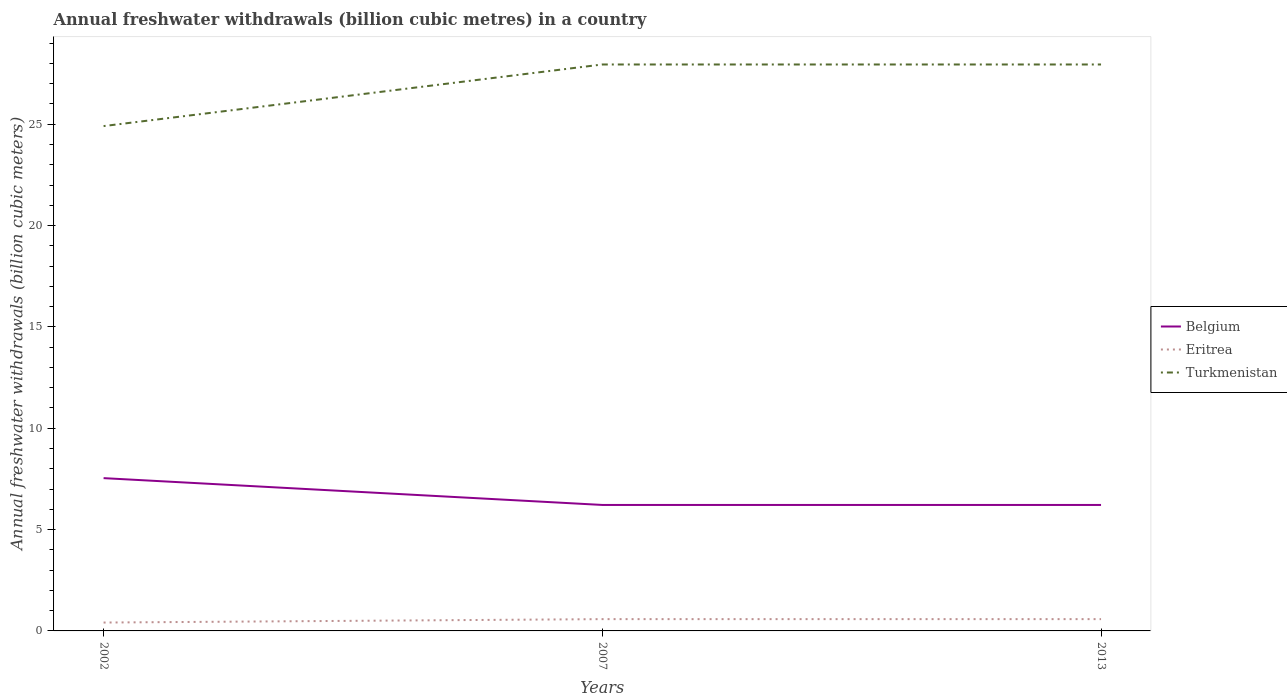Across all years, what is the maximum annual freshwater withdrawals in Belgium?
Give a very brief answer. 6.22. What is the total annual freshwater withdrawals in Eritrea in the graph?
Provide a succinct answer. 0. What is the difference between the highest and the second highest annual freshwater withdrawals in Turkmenistan?
Your answer should be very brief. 3.04. How many years are there in the graph?
Provide a succinct answer. 3. Does the graph contain any zero values?
Give a very brief answer. No. Where does the legend appear in the graph?
Your answer should be compact. Center right. How are the legend labels stacked?
Your response must be concise. Vertical. What is the title of the graph?
Ensure brevity in your answer.  Annual freshwater withdrawals (billion cubic metres) in a country. What is the label or title of the Y-axis?
Offer a very short reply. Annual freshwater withdrawals (billion cubic meters). What is the Annual freshwater withdrawals (billion cubic meters) in Belgium in 2002?
Make the answer very short. 7.54. What is the Annual freshwater withdrawals (billion cubic meters) of Eritrea in 2002?
Your response must be concise. 0.41. What is the Annual freshwater withdrawals (billion cubic meters) of Turkmenistan in 2002?
Keep it short and to the point. 24.91. What is the Annual freshwater withdrawals (billion cubic meters) of Belgium in 2007?
Ensure brevity in your answer.  6.22. What is the Annual freshwater withdrawals (billion cubic meters) of Eritrea in 2007?
Make the answer very short. 0.58. What is the Annual freshwater withdrawals (billion cubic meters) in Turkmenistan in 2007?
Your response must be concise. 27.95. What is the Annual freshwater withdrawals (billion cubic meters) in Belgium in 2013?
Offer a terse response. 6.22. What is the Annual freshwater withdrawals (billion cubic meters) of Eritrea in 2013?
Ensure brevity in your answer.  0.58. What is the Annual freshwater withdrawals (billion cubic meters) in Turkmenistan in 2013?
Make the answer very short. 27.95. Across all years, what is the maximum Annual freshwater withdrawals (billion cubic meters) in Belgium?
Keep it short and to the point. 7.54. Across all years, what is the maximum Annual freshwater withdrawals (billion cubic meters) of Eritrea?
Keep it short and to the point. 0.58. Across all years, what is the maximum Annual freshwater withdrawals (billion cubic meters) in Turkmenistan?
Make the answer very short. 27.95. Across all years, what is the minimum Annual freshwater withdrawals (billion cubic meters) in Belgium?
Provide a succinct answer. 6.22. Across all years, what is the minimum Annual freshwater withdrawals (billion cubic meters) in Eritrea?
Offer a very short reply. 0.41. Across all years, what is the minimum Annual freshwater withdrawals (billion cubic meters) of Turkmenistan?
Keep it short and to the point. 24.91. What is the total Annual freshwater withdrawals (billion cubic meters) in Belgium in the graph?
Your answer should be very brief. 19.97. What is the total Annual freshwater withdrawals (billion cubic meters) in Eritrea in the graph?
Your answer should be very brief. 1.58. What is the total Annual freshwater withdrawals (billion cubic meters) of Turkmenistan in the graph?
Make the answer very short. 80.81. What is the difference between the Annual freshwater withdrawals (billion cubic meters) of Belgium in 2002 and that in 2007?
Your response must be concise. 1.32. What is the difference between the Annual freshwater withdrawals (billion cubic meters) of Eritrea in 2002 and that in 2007?
Your answer should be very brief. -0.17. What is the difference between the Annual freshwater withdrawals (billion cubic meters) of Turkmenistan in 2002 and that in 2007?
Your response must be concise. -3.04. What is the difference between the Annual freshwater withdrawals (billion cubic meters) of Belgium in 2002 and that in 2013?
Keep it short and to the point. 1.32. What is the difference between the Annual freshwater withdrawals (billion cubic meters) in Eritrea in 2002 and that in 2013?
Provide a succinct answer. -0.17. What is the difference between the Annual freshwater withdrawals (billion cubic meters) of Turkmenistan in 2002 and that in 2013?
Your answer should be very brief. -3.04. What is the difference between the Annual freshwater withdrawals (billion cubic meters) of Belgium in 2002 and the Annual freshwater withdrawals (billion cubic meters) of Eritrea in 2007?
Your response must be concise. 6.96. What is the difference between the Annual freshwater withdrawals (billion cubic meters) of Belgium in 2002 and the Annual freshwater withdrawals (billion cubic meters) of Turkmenistan in 2007?
Ensure brevity in your answer.  -20.41. What is the difference between the Annual freshwater withdrawals (billion cubic meters) of Eritrea in 2002 and the Annual freshwater withdrawals (billion cubic meters) of Turkmenistan in 2007?
Keep it short and to the point. -27.54. What is the difference between the Annual freshwater withdrawals (billion cubic meters) of Belgium in 2002 and the Annual freshwater withdrawals (billion cubic meters) of Eritrea in 2013?
Provide a succinct answer. 6.96. What is the difference between the Annual freshwater withdrawals (billion cubic meters) in Belgium in 2002 and the Annual freshwater withdrawals (billion cubic meters) in Turkmenistan in 2013?
Make the answer very short. -20.41. What is the difference between the Annual freshwater withdrawals (billion cubic meters) of Eritrea in 2002 and the Annual freshwater withdrawals (billion cubic meters) of Turkmenistan in 2013?
Keep it short and to the point. -27.54. What is the difference between the Annual freshwater withdrawals (billion cubic meters) of Belgium in 2007 and the Annual freshwater withdrawals (billion cubic meters) of Eritrea in 2013?
Keep it short and to the point. 5.63. What is the difference between the Annual freshwater withdrawals (billion cubic meters) of Belgium in 2007 and the Annual freshwater withdrawals (billion cubic meters) of Turkmenistan in 2013?
Make the answer very short. -21.73. What is the difference between the Annual freshwater withdrawals (billion cubic meters) in Eritrea in 2007 and the Annual freshwater withdrawals (billion cubic meters) in Turkmenistan in 2013?
Keep it short and to the point. -27.37. What is the average Annual freshwater withdrawals (billion cubic meters) in Belgium per year?
Provide a succinct answer. 6.66. What is the average Annual freshwater withdrawals (billion cubic meters) in Eritrea per year?
Ensure brevity in your answer.  0.53. What is the average Annual freshwater withdrawals (billion cubic meters) in Turkmenistan per year?
Offer a very short reply. 26.94. In the year 2002, what is the difference between the Annual freshwater withdrawals (billion cubic meters) in Belgium and Annual freshwater withdrawals (billion cubic meters) in Eritrea?
Keep it short and to the point. 7.13. In the year 2002, what is the difference between the Annual freshwater withdrawals (billion cubic meters) in Belgium and Annual freshwater withdrawals (billion cubic meters) in Turkmenistan?
Make the answer very short. -17.37. In the year 2002, what is the difference between the Annual freshwater withdrawals (billion cubic meters) in Eritrea and Annual freshwater withdrawals (billion cubic meters) in Turkmenistan?
Ensure brevity in your answer.  -24.5. In the year 2007, what is the difference between the Annual freshwater withdrawals (billion cubic meters) of Belgium and Annual freshwater withdrawals (billion cubic meters) of Eritrea?
Make the answer very short. 5.63. In the year 2007, what is the difference between the Annual freshwater withdrawals (billion cubic meters) of Belgium and Annual freshwater withdrawals (billion cubic meters) of Turkmenistan?
Keep it short and to the point. -21.73. In the year 2007, what is the difference between the Annual freshwater withdrawals (billion cubic meters) of Eritrea and Annual freshwater withdrawals (billion cubic meters) of Turkmenistan?
Make the answer very short. -27.37. In the year 2013, what is the difference between the Annual freshwater withdrawals (billion cubic meters) in Belgium and Annual freshwater withdrawals (billion cubic meters) in Eritrea?
Provide a short and direct response. 5.63. In the year 2013, what is the difference between the Annual freshwater withdrawals (billion cubic meters) of Belgium and Annual freshwater withdrawals (billion cubic meters) of Turkmenistan?
Offer a very short reply. -21.73. In the year 2013, what is the difference between the Annual freshwater withdrawals (billion cubic meters) of Eritrea and Annual freshwater withdrawals (billion cubic meters) of Turkmenistan?
Keep it short and to the point. -27.37. What is the ratio of the Annual freshwater withdrawals (billion cubic meters) in Belgium in 2002 to that in 2007?
Offer a very short reply. 1.21. What is the ratio of the Annual freshwater withdrawals (billion cubic meters) in Eritrea in 2002 to that in 2007?
Offer a very short reply. 0.71. What is the ratio of the Annual freshwater withdrawals (billion cubic meters) in Turkmenistan in 2002 to that in 2007?
Make the answer very short. 0.89. What is the ratio of the Annual freshwater withdrawals (billion cubic meters) of Belgium in 2002 to that in 2013?
Give a very brief answer. 1.21. What is the ratio of the Annual freshwater withdrawals (billion cubic meters) in Eritrea in 2002 to that in 2013?
Provide a succinct answer. 0.71. What is the ratio of the Annual freshwater withdrawals (billion cubic meters) of Turkmenistan in 2002 to that in 2013?
Offer a terse response. 0.89. What is the ratio of the Annual freshwater withdrawals (billion cubic meters) of Eritrea in 2007 to that in 2013?
Provide a succinct answer. 1. What is the ratio of the Annual freshwater withdrawals (billion cubic meters) in Turkmenistan in 2007 to that in 2013?
Your answer should be very brief. 1. What is the difference between the highest and the second highest Annual freshwater withdrawals (billion cubic meters) of Belgium?
Your answer should be very brief. 1.32. What is the difference between the highest and the second highest Annual freshwater withdrawals (billion cubic meters) of Eritrea?
Keep it short and to the point. 0. What is the difference between the highest and the lowest Annual freshwater withdrawals (billion cubic meters) in Belgium?
Your answer should be compact. 1.32. What is the difference between the highest and the lowest Annual freshwater withdrawals (billion cubic meters) in Eritrea?
Your answer should be very brief. 0.17. What is the difference between the highest and the lowest Annual freshwater withdrawals (billion cubic meters) of Turkmenistan?
Give a very brief answer. 3.04. 